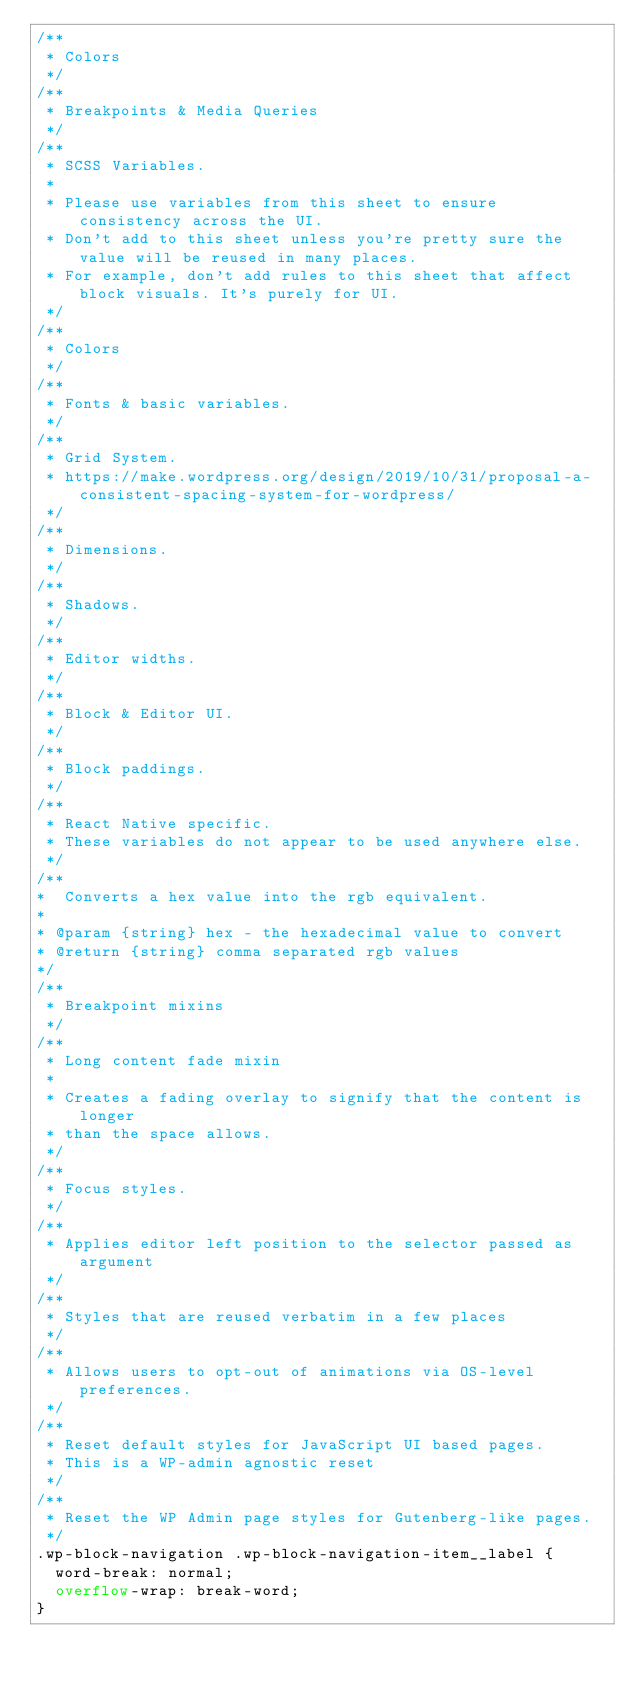Convert code to text. <code><loc_0><loc_0><loc_500><loc_500><_CSS_>/**
 * Colors
 */
/**
 * Breakpoints & Media Queries
 */
/**
 * SCSS Variables.
 *
 * Please use variables from this sheet to ensure consistency across the UI.
 * Don't add to this sheet unless you're pretty sure the value will be reused in many places.
 * For example, don't add rules to this sheet that affect block visuals. It's purely for UI.
 */
/**
 * Colors
 */
/**
 * Fonts & basic variables.
 */
/**
 * Grid System.
 * https://make.wordpress.org/design/2019/10/31/proposal-a-consistent-spacing-system-for-wordpress/
 */
/**
 * Dimensions.
 */
/**
 * Shadows.
 */
/**
 * Editor widths.
 */
/**
 * Block & Editor UI.
 */
/**
 * Block paddings.
 */
/**
 * React Native specific.
 * These variables do not appear to be used anywhere else.
 */
/**
*  Converts a hex value into the rgb equivalent.
*
* @param {string} hex - the hexadecimal value to convert
* @return {string} comma separated rgb values
*/
/**
 * Breakpoint mixins
 */
/**
 * Long content fade mixin
 *
 * Creates a fading overlay to signify that the content is longer
 * than the space allows.
 */
/**
 * Focus styles.
 */
/**
 * Applies editor left position to the selector passed as argument
 */
/**
 * Styles that are reused verbatim in a few places
 */
/**
 * Allows users to opt-out of animations via OS-level preferences.
 */
/**
 * Reset default styles for JavaScript UI based pages.
 * This is a WP-admin agnostic reset
 */
/**
 * Reset the WP Admin page styles for Gutenberg-like pages.
 */
.wp-block-navigation .wp-block-navigation-item__label {
  word-break: normal;
  overflow-wrap: break-word;
}</code> 